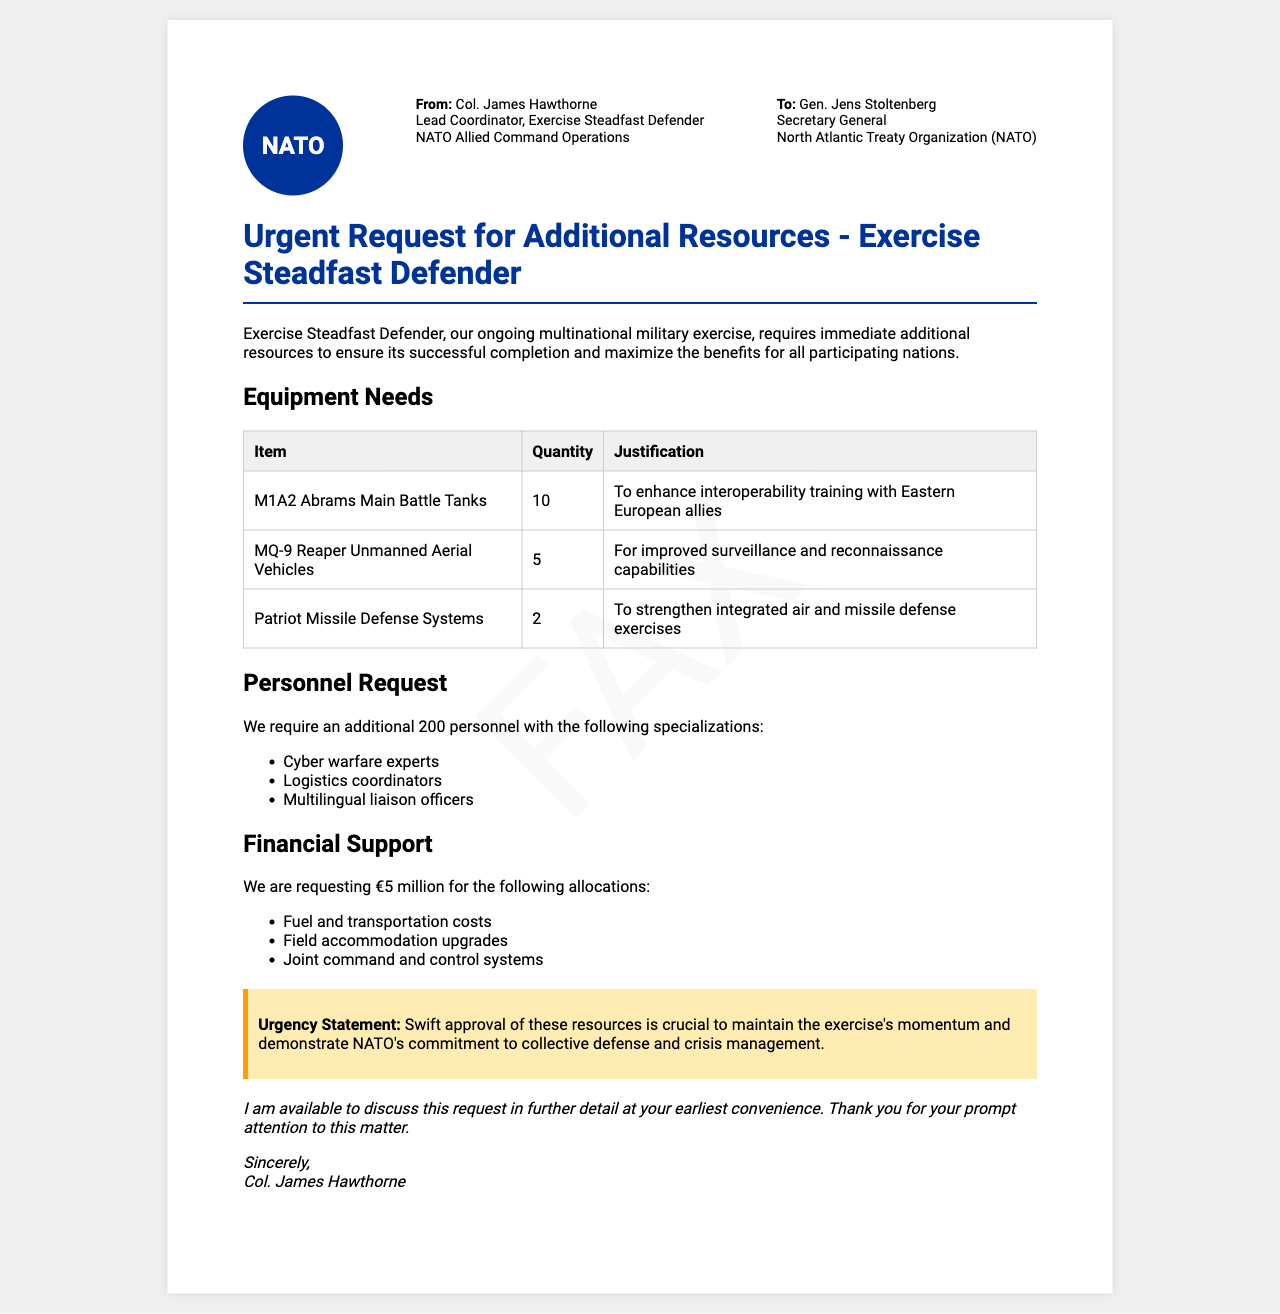What is the name of the exercise? The document states that the exercise is called "Exercise Steadfast Defender."
Answer: Exercise Steadfast Defender Who is the sender of the fax? The sender of the fax is Col. James Hawthorne, as mentioned in the document.
Answer: Col. James Hawthorne How many M1A2 Abrams Main Battle Tanks are requested? The document specifies a request for 10 M1A2 Abrams Main Battle Tanks.
Answer: 10 What is the total financial support requested? The total amount of financial support requested is €5 million, as stated in the document.
Answer: €5 million What specialized personnel is needed? The request includes personnel with specializations such as cyber warfare experts, logistics coordinators, and multilingual liaison officers.
Answer: Cyber warfare experts, logistics coordinators, multilingual liaison officers What is the urgency statement regarding the resource request? The urgency statement highlights the need for swift approval to maintain the exercise's momentum and NATO's commitment.
Answer: Swift approval is crucial How many additional personnel are requested? The document requests an additional 200 personnel.
Answer: 200 What is the justification for requesting more Patriot Missile Defense Systems? The justification in the document is to strengthen integrated air and missile defense exercises.
Answer: To strengthen integrated air and missile defense exercises What organization is the fax addressed to? The fax is addressed to the North Atlantic Treaty Organization (NATO).
Answer: North Atlantic Treaty Organization (NATO) 